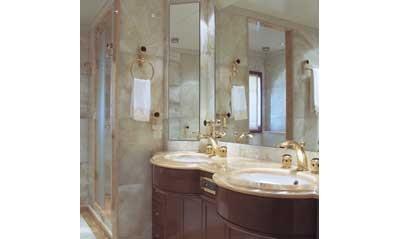How many forks are in the picture?
Give a very brief answer. 0. 